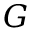Convert formula to latex. <formula><loc_0><loc_0><loc_500><loc_500>G</formula> 